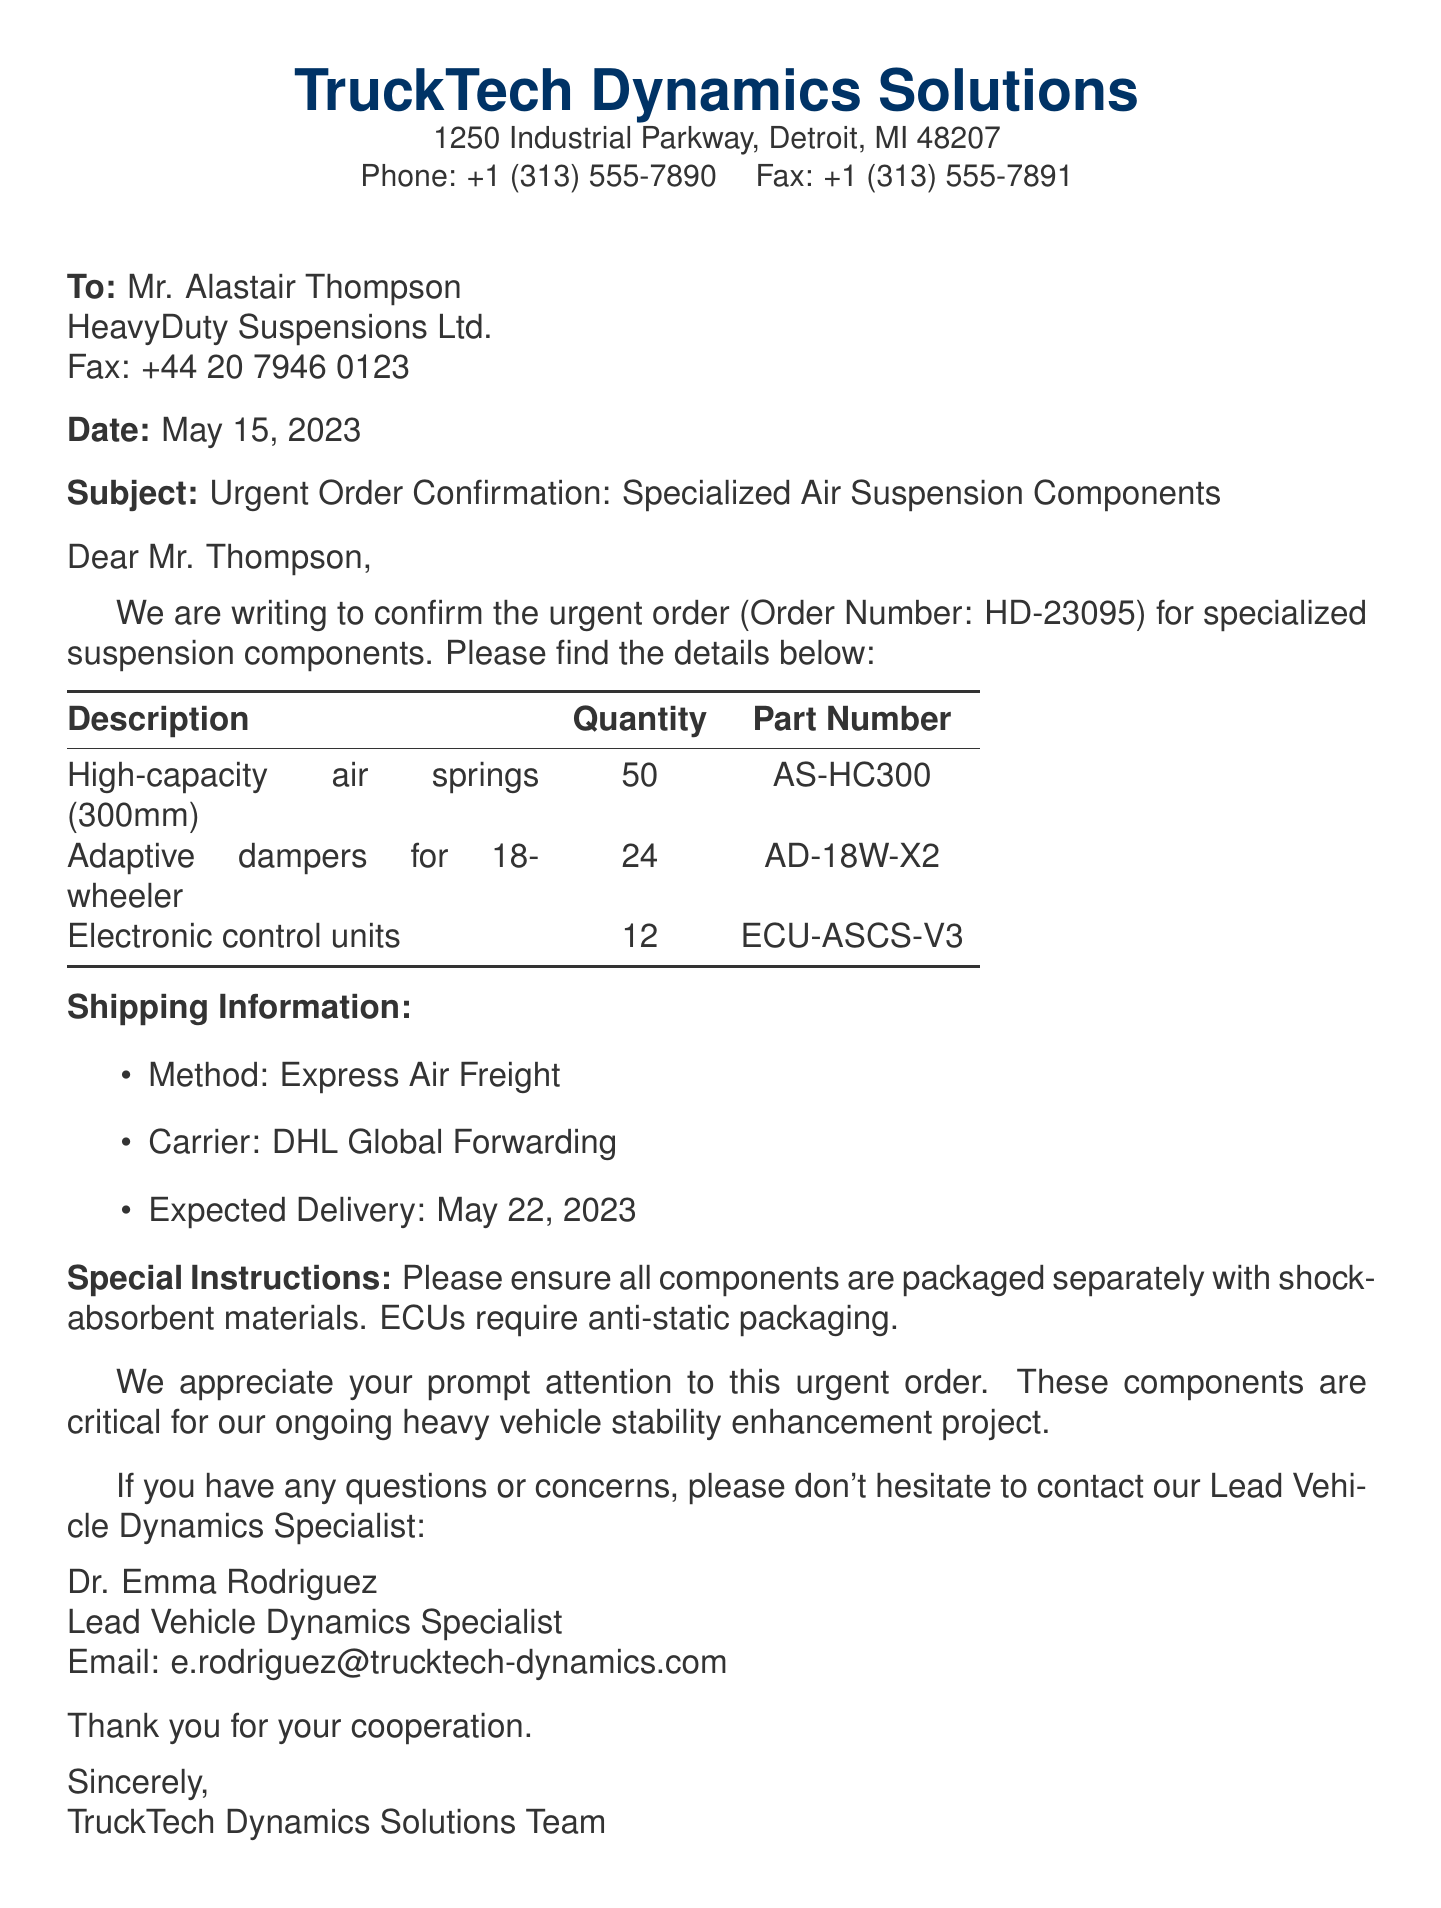what is the order number? The order number is specified in the document as HD-23095.
Answer: HD-23095 who is the recipient of the fax? The recipient's name and company details are provided in the fax, including Mr. Alastair Thompson and HeavyDuty Suspensions Ltd.
Answer: Mr. Alastair Thompson how many high-capacity air springs are ordered? The quantity of high-capacity air springs is stated in the order table as 50.
Answer: 50 what is the expected delivery date? The expected delivery date is explicitly mentioned in the shipping information section of the document as May 22, 2023.
Answer: May 22, 2023 which shipping method is used? The shipping method is outlined in the document and is specified as Express Air Freight.
Answer: Express Air Freight what are the special packaging instructions for ECUs? The document indicates that ECUs require anti-static packaging, which is a specific instruction given.
Answer: anti-static packaging how many adaptive dampers for 18-wheelers are included in the order? The order details list the quantity of adaptive dampers for 18-wheelers as 24.
Answer: 24 who is the lead vehicle dynamics specialist? The fax provides the name and title of the lead vehicle dynamics specialist as Dr. Emma Rodriguez.
Answer: Dr. Emma Rodriguez what carrier will handle the shipment? The carrier for the shipment is specified in the shipping information section as DHL Global Forwarding.
Answer: DHL Global Forwarding 